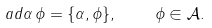<formula> <loc_0><loc_0><loc_500><loc_500>\ a d \alpha \, \phi = \{ \alpha , \phi \} , \quad \phi \in \mathcal { A } .</formula> 